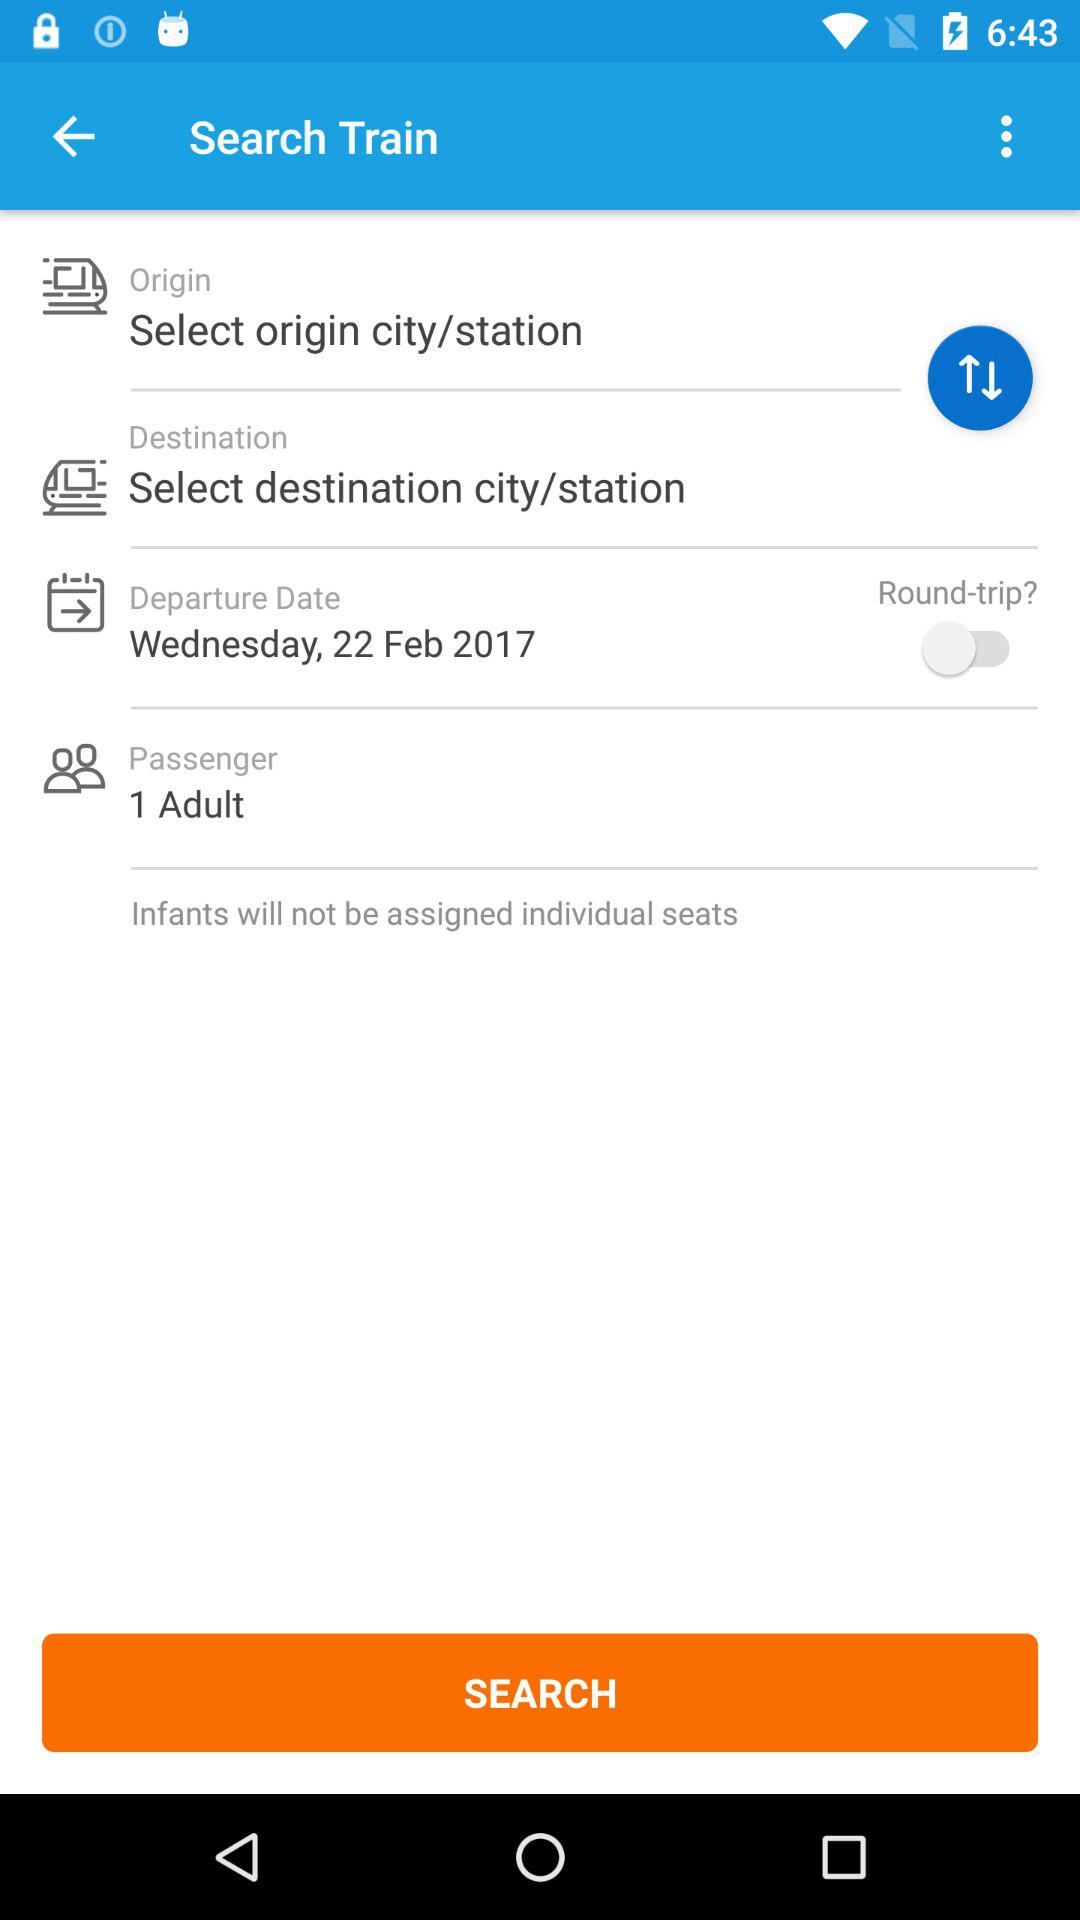What is the passenger count? The passenger count is 1. 